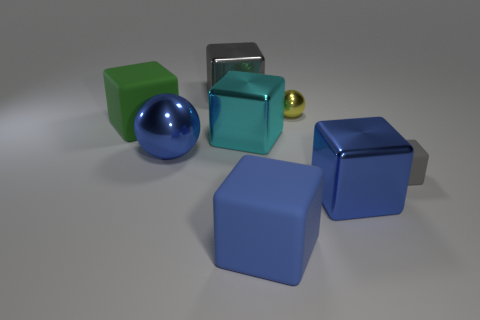How many gray matte cubes are there?
Your response must be concise. 1. The thing that is the same color as the small cube is what shape?
Your answer should be compact. Cube. The gray rubber object that is the same shape as the gray shiny thing is what size?
Make the answer very short. Small. There is a matte object in front of the blue metal block; is it the same shape as the small yellow metallic object?
Make the answer very short. No. What color is the big metallic block that is in front of the blue metal sphere?
Give a very brief answer. Blue. How many other things are the same size as the yellow shiny ball?
Make the answer very short. 1. Are there the same number of yellow shiny spheres behind the gray shiny object and small red objects?
Offer a very short reply. Yes. What number of large cyan blocks have the same material as the yellow ball?
Ensure brevity in your answer.  1. The other large thing that is the same material as the green thing is what color?
Your answer should be very brief. Blue. Does the cyan thing have the same shape as the gray metallic thing?
Give a very brief answer. Yes. 